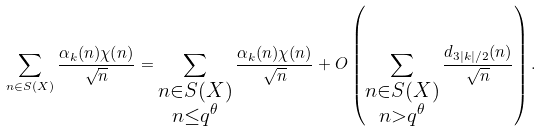Convert formula to latex. <formula><loc_0><loc_0><loc_500><loc_500>\sum _ { n \in S ( X ) } \frac { \alpha _ { k } ( n ) \chi ( n ) } { \sqrt { n } } = \sum _ { \substack { n \in S ( X ) \\ n \leq q ^ { \theta } } } \frac { \alpha _ { k } ( n ) \chi ( n ) } { \sqrt { n } } + O \left ( \sum _ { \substack { n \in S ( X ) \\ n > q ^ { \theta } } } \frac { d _ { 3 | k | / 2 } ( n ) } { \sqrt { n } } \right ) .</formula> 